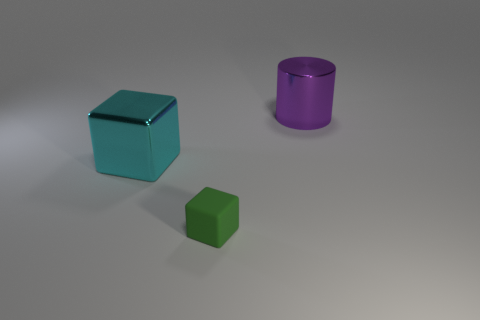Subtract all cubes. How many objects are left? 1 Subtract all green cylinders. How many green blocks are left? 1 Add 3 cylinders. How many objects exist? 6 Subtract 0 blue cubes. How many objects are left? 3 Subtract 2 blocks. How many blocks are left? 0 Subtract all brown blocks. Subtract all cyan balls. How many blocks are left? 2 Subtract all big cyan metal spheres. Subtract all tiny green things. How many objects are left? 2 Add 3 cyan objects. How many cyan objects are left? 4 Add 3 big shiny cylinders. How many big shiny cylinders exist? 4 